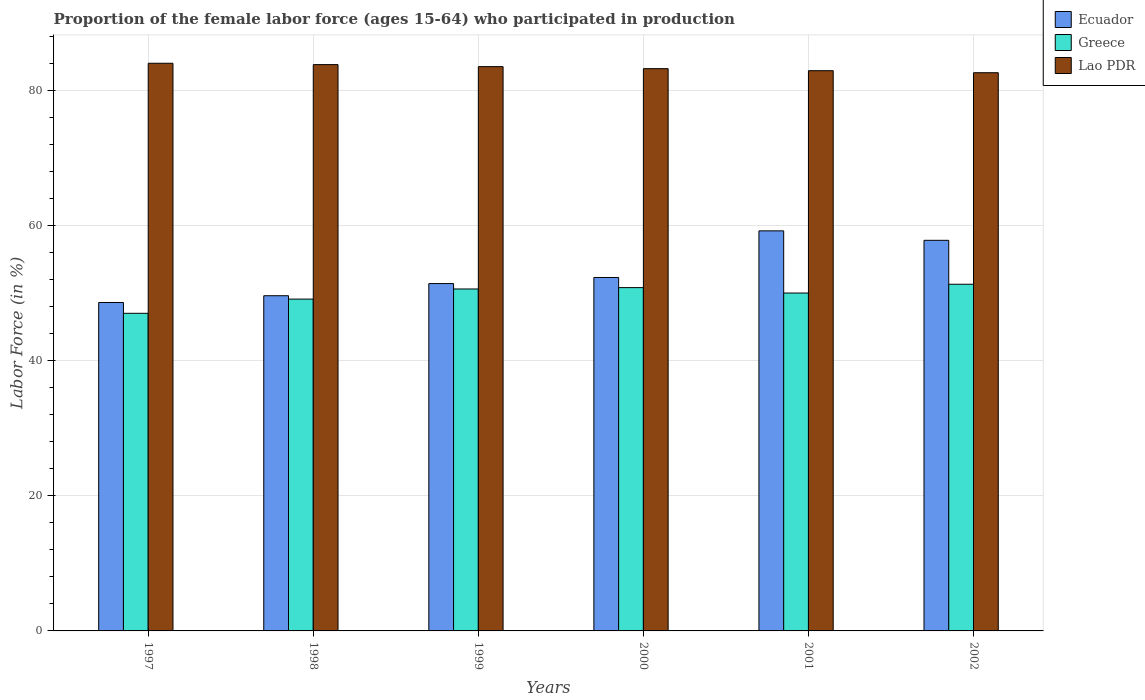Are the number of bars per tick equal to the number of legend labels?
Offer a very short reply. Yes. Are the number of bars on each tick of the X-axis equal?
Your answer should be very brief. Yes. How many bars are there on the 3rd tick from the right?
Your response must be concise. 3. What is the label of the 2nd group of bars from the left?
Your answer should be compact. 1998. In how many cases, is the number of bars for a given year not equal to the number of legend labels?
Provide a succinct answer. 0. What is the proportion of the female labor force who participated in production in Greece in 2001?
Offer a terse response. 50. Across all years, what is the maximum proportion of the female labor force who participated in production in Greece?
Provide a short and direct response. 51.3. Across all years, what is the minimum proportion of the female labor force who participated in production in Lao PDR?
Give a very brief answer. 82.6. In which year was the proportion of the female labor force who participated in production in Ecuador maximum?
Ensure brevity in your answer.  2001. What is the total proportion of the female labor force who participated in production in Lao PDR in the graph?
Your answer should be compact. 500. What is the difference between the proportion of the female labor force who participated in production in Ecuador in 2001 and that in 2002?
Your response must be concise. 1.4. What is the difference between the proportion of the female labor force who participated in production in Lao PDR in 2000 and the proportion of the female labor force who participated in production in Ecuador in 1999?
Provide a succinct answer. 31.8. What is the average proportion of the female labor force who participated in production in Lao PDR per year?
Your answer should be compact. 83.33. In the year 1999, what is the difference between the proportion of the female labor force who participated in production in Greece and proportion of the female labor force who participated in production in Ecuador?
Ensure brevity in your answer.  -0.8. In how many years, is the proportion of the female labor force who participated in production in Greece greater than 64 %?
Give a very brief answer. 0. What is the ratio of the proportion of the female labor force who participated in production in Lao PDR in 1997 to that in 1998?
Your answer should be compact. 1. Is the proportion of the female labor force who participated in production in Ecuador in 2001 less than that in 2002?
Your answer should be very brief. No. Is the difference between the proportion of the female labor force who participated in production in Greece in 1997 and 2000 greater than the difference between the proportion of the female labor force who participated in production in Ecuador in 1997 and 2000?
Offer a terse response. No. What is the difference between the highest and the lowest proportion of the female labor force who participated in production in Ecuador?
Your response must be concise. 10.6. What does the 2nd bar from the right in 2000 represents?
Your response must be concise. Greece. Is it the case that in every year, the sum of the proportion of the female labor force who participated in production in Lao PDR and proportion of the female labor force who participated in production in Greece is greater than the proportion of the female labor force who participated in production in Ecuador?
Your answer should be compact. Yes. Are all the bars in the graph horizontal?
Provide a succinct answer. No. How many years are there in the graph?
Your answer should be very brief. 6. Does the graph contain grids?
Provide a succinct answer. Yes. How many legend labels are there?
Your response must be concise. 3. What is the title of the graph?
Your response must be concise. Proportion of the female labor force (ages 15-64) who participated in production. Does "Iraq" appear as one of the legend labels in the graph?
Provide a short and direct response. No. What is the Labor Force (in %) in Ecuador in 1997?
Make the answer very short. 48.6. What is the Labor Force (in %) in Ecuador in 1998?
Provide a short and direct response. 49.6. What is the Labor Force (in %) of Greece in 1998?
Ensure brevity in your answer.  49.1. What is the Labor Force (in %) of Lao PDR in 1998?
Ensure brevity in your answer.  83.8. What is the Labor Force (in %) in Ecuador in 1999?
Provide a succinct answer. 51.4. What is the Labor Force (in %) in Greece in 1999?
Provide a short and direct response. 50.6. What is the Labor Force (in %) in Lao PDR in 1999?
Your answer should be compact. 83.5. What is the Labor Force (in %) of Ecuador in 2000?
Your answer should be compact. 52.3. What is the Labor Force (in %) in Greece in 2000?
Ensure brevity in your answer.  50.8. What is the Labor Force (in %) of Lao PDR in 2000?
Make the answer very short. 83.2. What is the Labor Force (in %) in Ecuador in 2001?
Keep it short and to the point. 59.2. What is the Labor Force (in %) of Lao PDR in 2001?
Your answer should be very brief. 82.9. What is the Labor Force (in %) in Ecuador in 2002?
Provide a short and direct response. 57.8. What is the Labor Force (in %) of Greece in 2002?
Provide a short and direct response. 51.3. What is the Labor Force (in %) of Lao PDR in 2002?
Give a very brief answer. 82.6. Across all years, what is the maximum Labor Force (in %) of Ecuador?
Offer a very short reply. 59.2. Across all years, what is the maximum Labor Force (in %) in Greece?
Provide a succinct answer. 51.3. Across all years, what is the maximum Labor Force (in %) of Lao PDR?
Provide a succinct answer. 84. Across all years, what is the minimum Labor Force (in %) in Ecuador?
Your answer should be compact. 48.6. Across all years, what is the minimum Labor Force (in %) in Greece?
Your answer should be very brief. 47. Across all years, what is the minimum Labor Force (in %) of Lao PDR?
Offer a terse response. 82.6. What is the total Labor Force (in %) of Ecuador in the graph?
Provide a short and direct response. 318.9. What is the total Labor Force (in %) in Greece in the graph?
Ensure brevity in your answer.  298.8. What is the total Labor Force (in %) of Lao PDR in the graph?
Your response must be concise. 500. What is the difference between the Labor Force (in %) in Greece in 1997 and that in 1998?
Give a very brief answer. -2.1. What is the difference between the Labor Force (in %) of Lao PDR in 1997 and that in 1999?
Offer a very short reply. 0.5. What is the difference between the Labor Force (in %) in Greece in 1997 and that in 2001?
Your answer should be very brief. -3. What is the difference between the Labor Force (in %) of Lao PDR in 1998 and that in 1999?
Keep it short and to the point. 0.3. What is the difference between the Labor Force (in %) of Greece in 1998 and that in 2000?
Ensure brevity in your answer.  -1.7. What is the difference between the Labor Force (in %) of Ecuador in 1998 and that in 2001?
Keep it short and to the point. -9.6. What is the difference between the Labor Force (in %) of Lao PDR in 1998 and that in 2001?
Provide a succinct answer. 0.9. What is the difference between the Labor Force (in %) in Greece in 1998 and that in 2002?
Your answer should be compact. -2.2. What is the difference between the Labor Force (in %) in Ecuador in 1999 and that in 2001?
Your answer should be compact. -7.8. What is the difference between the Labor Force (in %) of Greece in 1999 and that in 2001?
Your answer should be very brief. 0.6. What is the difference between the Labor Force (in %) in Lao PDR in 1999 and that in 2001?
Provide a short and direct response. 0.6. What is the difference between the Labor Force (in %) in Ecuador in 1999 and that in 2002?
Provide a short and direct response. -6.4. What is the difference between the Labor Force (in %) in Greece in 2000 and that in 2001?
Make the answer very short. 0.8. What is the difference between the Labor Force (in %) in Lao PDR in 2000 and that in 2002?
Offer a terse response. 0.6. What is the difference between the Labor Force (in %) in Ecuador in 2001 and that in 2002?
Make the answer very short. 1.4. What is the difference between the Labor Force (in %) in Ecuador in 1997 and the Labor Force (in %) in Lao PDR in 1998?
Your answer should be compact. -35.2. What is the difference between the Labor Force (in %) of Greece in 1997 and the Labor Force (in %) of Lao PDR in 1998?
Keep it short and to the point. -36.8. What is the difference between the Labor Force (in %) of Ecuador in 1997 and the Labor Force (in %) of Greece in 1999?
Your response must be concise. -2. What is the difference between the Labor Force (in %) in Ecuador in 1997 and the Labor Force (in %) in Lao PDR in 1999?
Your answer should be very brief. -34.9. What is the difference between the Labor Force (in %) of Greece in 1997 and the Labor Force (in %) of Lao PDR in 1999?
Your answer should be very brief. -36.5. What is the difference between the Labor Force (in %) in Ecuador in 1997 and the Labor Force (in %) in Greece in 2000?
Provide a short and direct response. -2.2. What is the difference between the Labor Force (in %) of Ecuador in 1997 and the Labor Force (in %) of Lao PDR in 2000?
Make the answer very short. -34.6. What is the difference between the Labor Force (in %) of Greece in 1997 and the Labor Force (in %) of Lao PDR in 2000?
Give a very brief answer. -36.2. What is the difference between the Labor Force (in %) in Ecuador in 1997 and the Labor Force (in %) in Greece in 2001?
Make the answer very short. -1.4. What is the difference between the Labor Force (in %) of Ecuador in 1997 and the Labor Force (in %) of Lao PDR in 2001?
Your answer should be compact. -34.3. What is the difference between the Labor Force (in %) in Greece in 1997 and the Labor Force (in %) in Lao PDR in 2001?
Provide a short and direct response. -35.9. What is the difference between the Labor Force (in %) of Ecuador in 1997 and the Labor Force (in %) of Lao PDR in 2002?
Ensure brevity in your answer.  -34. What is the difference between the Labor Force (in %) in Greece in 1997 and the Labor Force (in %) in Lao PDR in 2002?
Offer a very short reply. -35.6. What is the difference between the Labor Force (in %) of Ecuador in 1998 and the Labor Force (in %) of Lao PDR in 1999?
Ensure brevity in your answer.  -33.9. What is the difference between the Labor Force (in %) in Greece in 1998 and the Labor Force (in %) in Lao PDR in 1999?
Keep it short and to the point. -34.4. What is the difference between the Labor Force (in %) in Ecuador in 1998 and the Labor Force (in %) in Greece in 2000?
Your response must be concise. -1.2. What is the difference between the Labor Force (in %) of Ecuador in 1998 and the Labor Force (in %) of Lao PDR in 2000?
Keep it short and to the point. -33.6. What is the difference between the Labor Force (in %) in Greece in 1998 and the Labor Force (in %) in Lao PDR in 2000?
Your answer should be very brief. -34.1. What is the difference between the Labor Force (in %) of Ecuador in 1998 and the Labor Force (in %) of Greece in 2001?
Give a very brief answer. -0.4. What is the difference between the Labor Force (in %) of Ecuador in 1998 and the Labor Force (in %) of Lao PDR in 2001?
Make the answer very short. -33.3. What is the difference between the Labor Force (in %) of Greece in 1998 and the Labor Force (in %) of Lao PDR in 2001?
Keep it short and to the point. -33.8. What is the difference between the Labor Force (in %) in Ecuador in 1998 and the Labor Force (in %) in Greece in 2002?
Offer a very short reply. -1.7. What is the difference between the Labor Force (in %) of Ecuador in 1998 and the Labor Force (in %) of Lao PDR in 2002?
Your response must be concise. -33. What is the difference between the Labor Force (in %) in Greece in 1998 and the Labor Force (in %) in Lao PDR in 2002?
Keep it short and to the point. -33.5. What is the difference between the Labor Force (in %) of Ecuador in 1999 and the Labor Force (in %) of Lao PDR in 2000?
Offer a terse response. -31.8. What is the difference between the Labor Force (in %) in Greece in 1999 and the Labor Force (in %) in Lao PDR in 2000?
Provide a short and direct response. -32.6. What is the difference between the Labor Force (in %) in Ecuador in 1999 and the Labor Force (in %) in Greece in 2001?
Your answer should be compact. 1.4. What is the difference between the Labor Force (in %) in Ecuador in 1999 and the Labor Force (in %) in Lao PDR in 2001?
Give a very brief answer. -31.5. What is the difference between the Labor Force (in %) in Greece in 1999 and the Labor Force (in %) in Lao PDR in 2001?
Provide a short and direct response. -32.3. What is the difference between the Labor Force (in %) in Ecuador in 1999 and the Labor Force (in %) in Greece in 2002?
Your answer should be very brief. 0.1. What is the difference between the Labor Force (in %) in Ecuador in 1999 and the Labor Force (in %) in Lao PDR in 2002?
Provide a short and direct response. -31.2. What is the difference between the Labor Force (in %) in Greece in 1999 and the Labor Force (in %) in Lao PDR in 2002?
Give a very brief answer. -32. What is the difference between the Labor Force (in %) of Ecuador in 2000 and the Labor Force (in %) of Greece in 2001?
Your answer should be compact. 2.3. What is the difference between the Labor Force (in %) of Ecuador in 2000 and the Labor Force (in %) of Lao PDR in 2001?
Provide a succinct answer. -30.6. What is the difference between the Labor Force (in %) in Greece in 2000 and the Labor Force (in %) in Lao PDR in 2001?
Provide a succinct answer. -32.1. What is the difference between the Labor Force (in %) of Ecuador in 2000 and the Labor Force (in %) of Greece in 2002?
Your answer should be very brief. 1. What is the difference between the Labor Force (in %) in Ecuador in 2000 and the Labor Force (in %) in Lao PDR in 2002?
Offer a very short reply. -30.3. What is the difference between the Labor Force (in %) of Greece in 2000 and the Labor Force (in %) of Lao PDR in 2002?
Ensure brevity in your answer.  -31.8. What is the difference between the Labor Force (in %) of Ecuador in 2001 and the Labor Force (in %) of Lao PDR in 2002?
Your response must be concise. -23.4. What is the difference between the Labor Force (in %) in Greece in 2001 and the Labor Force (in %) in Lao PDR in 2002?
Ensure brevity in your answer.  -32.6. What is the average Labor Force (in %) in Ecuador per year?
Your answer should be compact. 53.15. What is the average Labor Force (in %) in Greece per year?
Ensure brevity in your answer.  49.8. What is the average Labor Force (in %) of Lao PDR per year?
Your answer should be very brief. 83.33. In the year 1997, what is the difference between the Labor Force (in %) of Ecuador and Labor Force (in %) of Lao PDR?
Your response must be concise. -35.4. In the year 1997, what is the difference between the Labor Force (in %) of Greece and Labor Force (in %) of Lao PDR?
Make the answer very short. -37. In the year 1998, what is the difference between the Labor Force (in %) of Ecuador and Labor Force (in %) of Lao PDR?
Offer a very short reply. -34.2. In the year 1998, what is the difference between the Labor Force (in %) in Greece and Labor Force (in %) in Lao PDR?
Ensure brevity in your answer.  -34.7. In the year 1999, what is the difference between the Labor Force (in %) in Ecuador and Labor Force (in %) in Greece?
Keep it short and to the point. 0.8. In the year 1999, what is the difference between the Labor Force (in %) of Ecuador and Labor Force (in %) of Lao PDR?
Ensure brevity in your answer.  -32.1. In the year 1999, what is the difference between the Labor Force (in %) in Greece and Labor Force (in %) in Lao PDR?
Provide a succinct answer. -32.9. In the year 2000, what is the difference between the Labor Force (in %) in Ecuador and Labor Force (in %) in Greece?
Your answer should be compact. 1.5. In the year 2000, what is the difference between the Labor Force (in %) in Ecuador and Labor Force (in %) in Lao PDR?
Give a very brief answer. -30.9. In the year 2000, what is the difference between the Labor Force (in %) in Greece and Labor Force (in %) in Lao PDR?
Offer a very short reply. -32.4. In the year 2001, what is the difference between the Labor Force (in %) of Ecuador and Labor Force (in %) of Lao PDR?
Your answer should be compact. -23.7. In the year 2001, what is the difference between the Labor Force (in %) in Greece and Labor Force (in %) in Lao PDR?
Offer a terse response. -32.9. In the year 2002, what is the difference between the Labor Force (in %) of Ecuador and Labor Force (in %) of Lao PDR?
Provide a succinct answer. -24.8. In the year 2002, what is the difference between the Labor Force (in %) of Greece and Labor Force (in %) of Lao PDR?
Your answer should be compact. -31.3. What is the ratio of the Labor Force (in %) of Ecuador in 1997 to that in 1998?
Provide a short and direct response. 0.98. What is the ratio of the Labor Force (in %) of Greece in 1997 to that in 1998?
Offer a terse response. 0.96. What is the ratio of the Labor Force (in %) of Ecuador in 1997 to that in 1999?
Offer a terse response. 0.95. What is the ratio of the Labor Force (in %) in Greece in 1997 to that in 1999?
Give a very brief answer. 0.93. What is the ratio of the Labor Force (in %) in Ecuador in 1997 to that in 2000?
Offer a very short reply. 0.93. What is the ratio of the Labor Force (in %) in Greece in 1997 to that in 2000?
Offer a very short reply. 0.93. What is the ratio of the Labor Force (in %) in Lao PDR in 1997 to that in 2000?
Provide a succinct answer. 1.01. What is the ratio of the Labor Force (in %) in Ecuador in 1997 to that in 2001?
Offer a very short reply. 0.82. What is the ratio of the Labor Force (in %) in Greece in 1997 to that in 2001?
Your answer should be compact. 0.94. What is the ratio of the Labor Force (in %) of Lao PDR in 1997 to that in 2001?
Offer a very short reply. 1.01. What is the ratio of the Labor Force (in %) of Ecuador in 1997 to that in 2002?
Provide a succinct answer. 0.84. What is the ratio of the Labor Force (in %) of Greece in 1997 to that in 2002?
Keep it short and to the point. 0.92. What is the ratio of the Labor Force (in %) in Lao PDR in 1997 to that in 2002?
Offer a terse response. 1.02. What is the ratio of the Labor Force (in %) in Ecuador in 1998 to that in 1999?
Your answer should be compact. 0.96. What is the ratio of the Labor Force (in %) in Greece in 1998 to that in 1999?
Provide a succinct answer. 0.97. What is the ratio of the Labor Force (in %) of Lao PDR in 1998 to that in 1999?
Your response must be concise. 1. What is the ratio of the Labor Force (in %) in Ecuador in 1998 to that in 2000?
Your answer should be compact. 0.95. What is the ratio of the Labor Force (in %) in Greece in 1998 to that in 2000?
Offer a very short reply. 0.97. What is the ratio of the Labor Force (in %) of Ecuador in 1998 to that in 2001?
Provide a succinct answer. 0.84. What is the ratio of the Labor Force (in %) in Lao PDR in 1998 to that in 2001?
Your answer should be compact. 1.01. What is the ratio of the Labor Force (in %) of Ecuador in 1998 to that in 2002?
Give a very brief answer. 0.86. What is the ratio of the Labor Force (in %) of Greece in 1998 to that in 2002?
Offer a terse response. 0.96. What is the ratio of the Labor Force (in %) in Lao PDR in 1998 to that in 2002?
Your answer should be compact. 1.01. What is the ratio of the Labor Force (in %) in Ecuador in 1999 to that in 2000?
Provide a short and direct response. 0.98. What is the ratio of the Labor Force (in %) in Lao PDR in 1999 to that in 2000?
Your answer should be very brief. 1. What is the ratio of the Labor Force (in %) in Ecuador in 1999 to that in 2001?
Keep it short and to the point. 0.87. What is the ratio of the Labor Force (in %) of Greece in 1999 to that in 2001?
Provide a succinct answer. 1.01. What is the ratio of the Labor Force (in %) in Lao PDR in 1999 to that in 2001?
Ensure brevity in your answer.  1.01. What is the ratio of the Labor Force (in %) of Ecuador in 1999 to that in 2002?
Provide a short and direct response. 0.89. What is the ratio of the Labor Force (in %) in Greece in 1999 to that in 2002?
Keep it short and to the point. 0.99. What is the ratio of the Labor Force (in %) in Lao PDR in 1999 to that in 2002?
Make the answer very short. 1.01. What is the ratio of the Labor Force (in %) of Ecuador in 2000 to that in 2001?
Ensure brevity in your answer.  0.88. What is the ratio of the Labor Force (in %) of Greece in 2000 to that in 2001?
Your answer should be very brief. 1.02. What is the ratio of the Labor Force (in %) in Ecuador in 2000 to that in 2002?
Your answer should be compact. 0.9. What is the ratio of the Labor Force (in %) of Greece in 2000 to that in 2002?
Offer a terse response. 0.99. What is the ratio of the Labor Force (in %) of Lao PDR in 2000 to that in 2002?
Your response must be concise. 1.01. What is the ratio of the Labor Force (in %) in Ecuador in 2001 to that in 2002?
Give a very brief answer. 1.02. What is the ratio of the Labor Force (in %) of Greece in 2001 to that in 2002?
Your answer should be very brief. 0.97. What is the ratio of the Labor Force (in %) of Lao PDR in 2001 to that in 2002?
Your answer should be very brief. 1. What is the difference between the highest and the second highest Labor Force (in %) of Greece?
Ensure brevity in your answer.  0.5. 